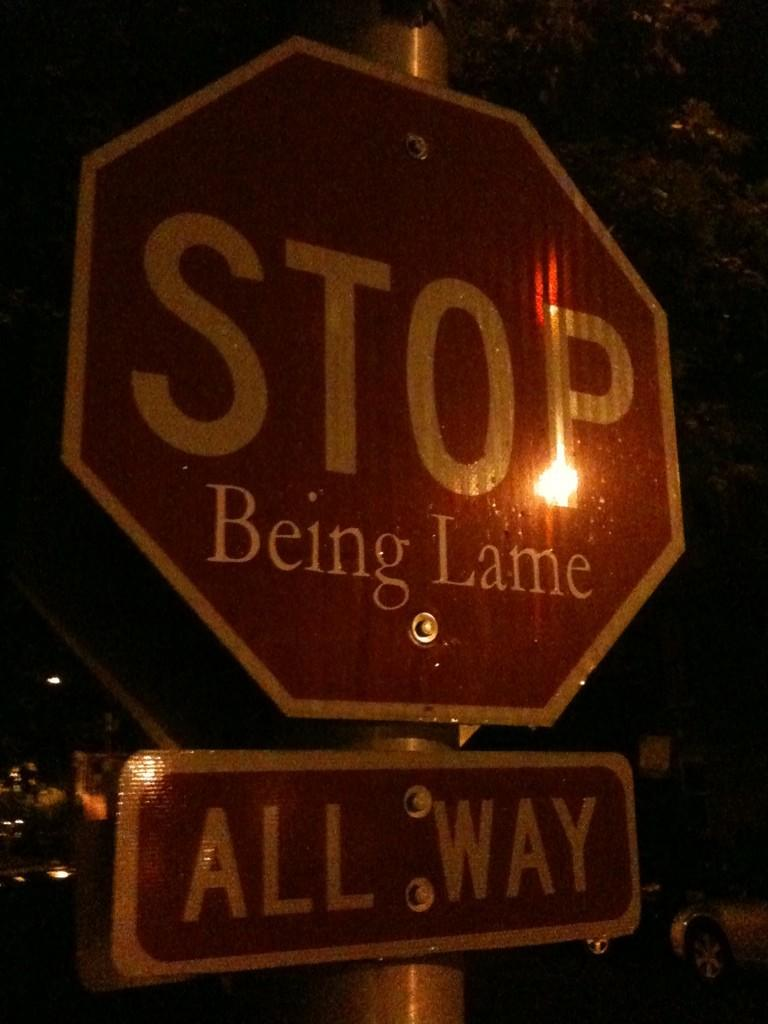Provide a one-sentence caption for the provided image. Big red and white stop sign with being lame wrote on it. 